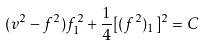Convert formula to latex. <formula><loc_0><loc_0><loc_500><loc_500>( v ^ { 2 } - f ^ { 2 } ) f _ { 1 } ^ { 2 } + \frac { 1 } { 4 } [ ( f ^ { 2 } ) _ { 1 } ] ^ { 2 } = C</formula> 